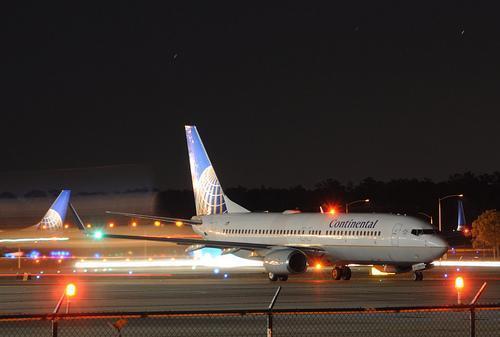How many airplanes are in the picture?
Give a very brief answer. 2. 